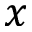<formula> <loc_0><loc_0><loc_500><loc_500>x</formula> 